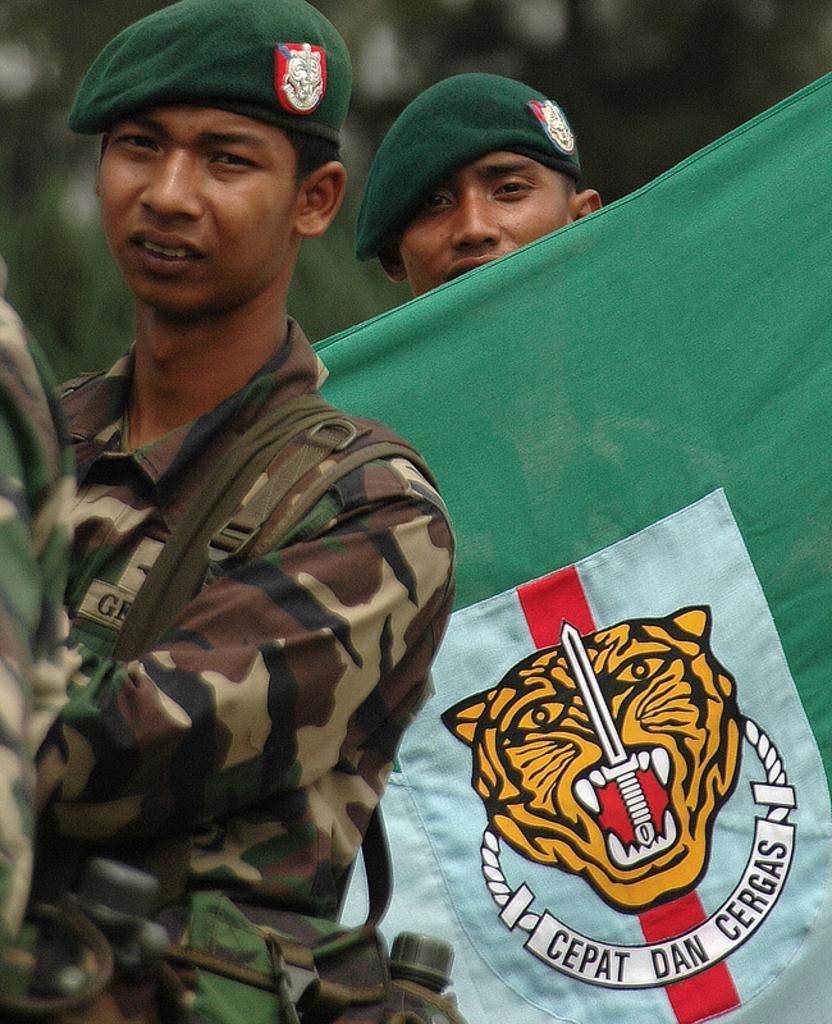How would you summarize this image in a sentence or two? In this image I can see three persons and I can see two of them are wearing uniforms and two of them are wearing green colour caps. On the right side of this image I can see a green and white colour cloth and on it I can see a logo. I can also see something is written on the cloth and I can see this image is blurry in the background. 